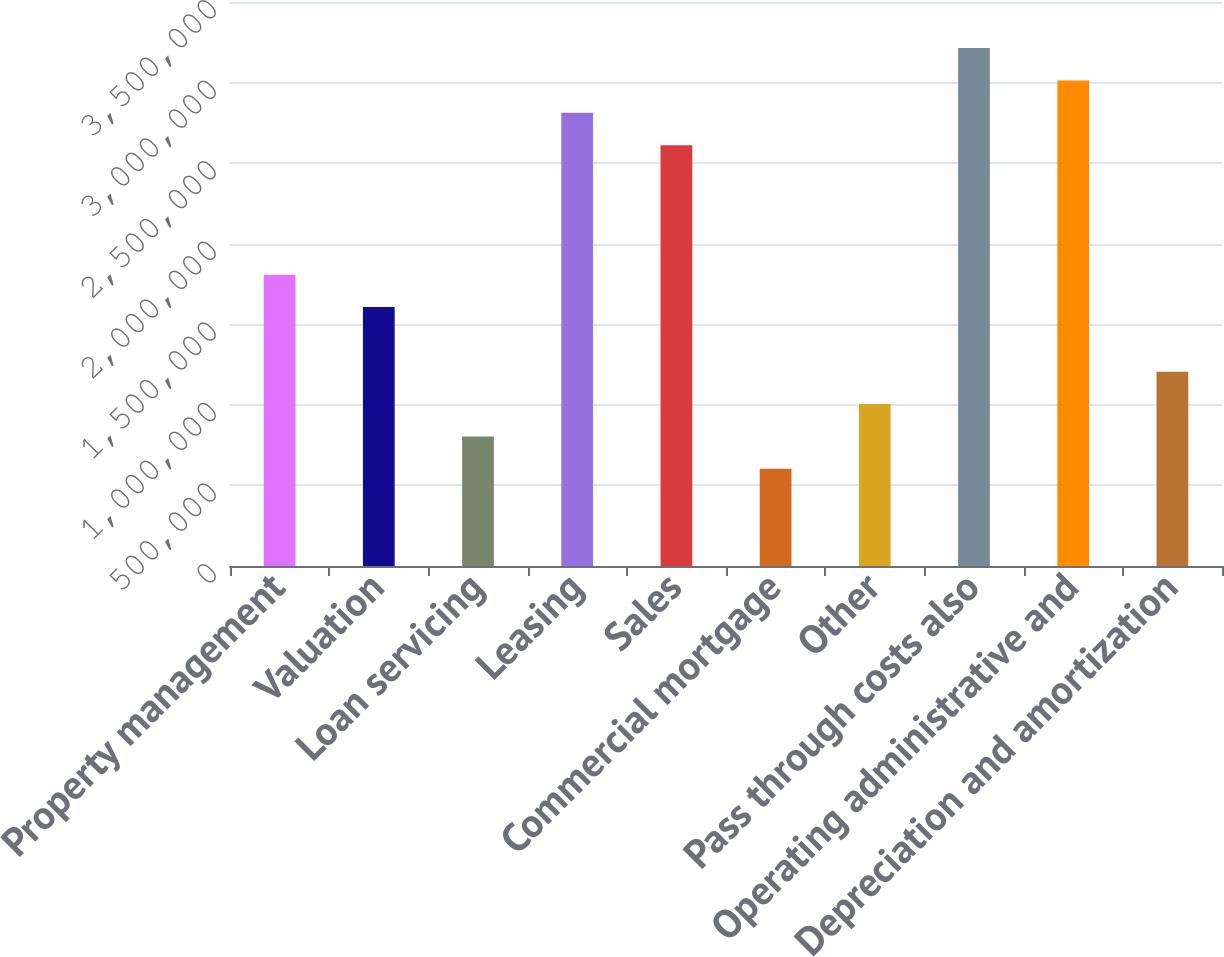<chart> <loc_0><loc_0><loc_500><loc_500><bar_chart><fcel>Property management<fcel>Valuation<fcel>Loan servicing<fcel>Leasing<fcel>Sales<fcel>Commercial mortgage<fcel>Other<fcel>Pass through costs also<fcel>Operating administrative and<fcel>Depreciation and amortization<nl><fcel>1.80817e+06<fcel>1.60727e+06<fcel>803668<fcel>2.81268e+06<fcel>2.61178e+06<fcel>602767<fcel>1.00457e+06<fcel>3.21448e+06<fcel>3.01358e+06<fcel>1.20547e+06<nl></chart> 